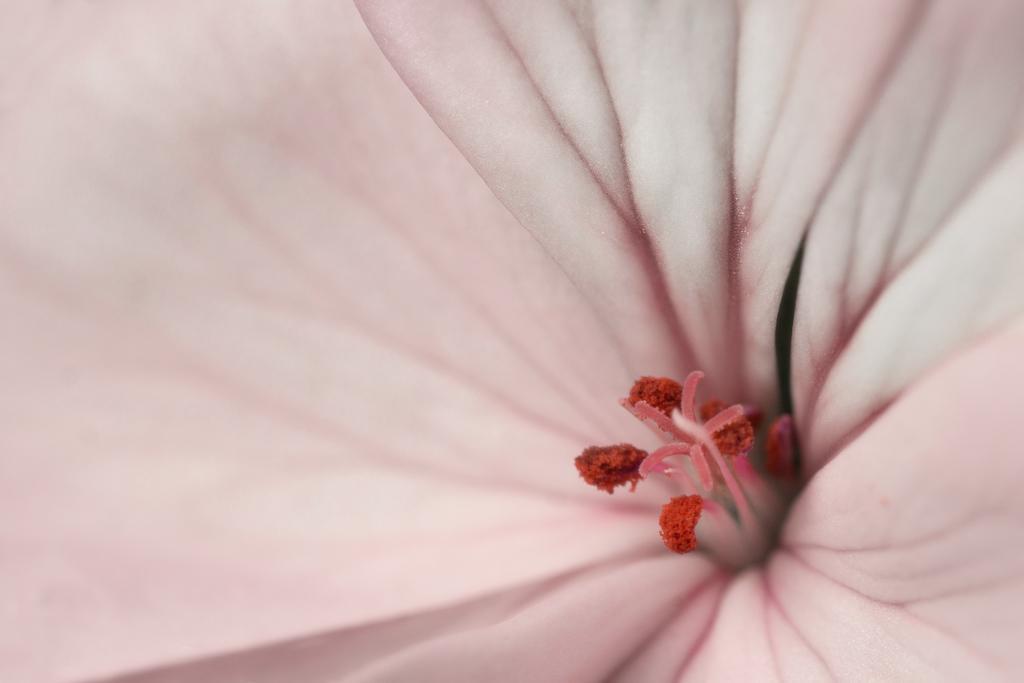Can you describe this image briefly? In this picture I can see a flower, which is of pink and red color. 